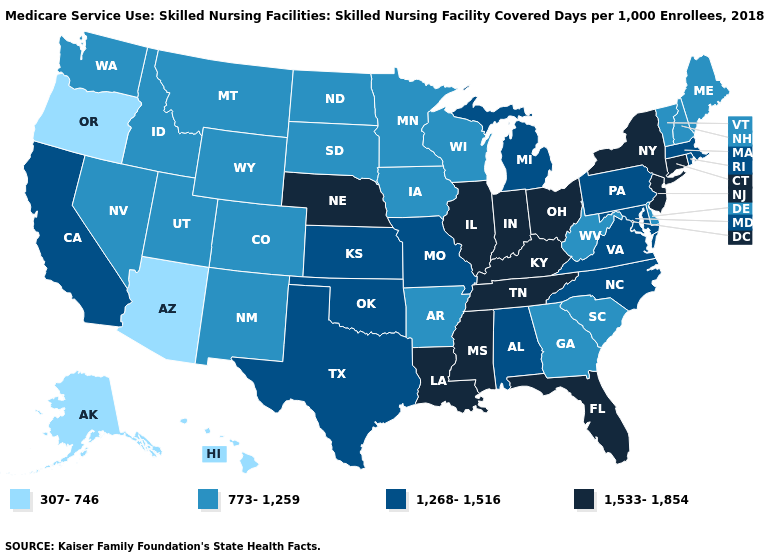Which states hav the highest value in the Northeast?
Concise answer only. Connecticut, New Jersey, New York. Which states have the lowest value in the Northeast?
Give a very brief answer. Maine, New Hampshire, Vermont. What is the value of Massachusetts?
Write a very short answer. 1,268-1,516. Name the states that have a value in the range 773-1,259?
Write a very short answer. Arkansas, Colorado, Delaware, Georgia, Idaho, Iowa, Maine, Minnesota, Montana, Nevada, New Hampshire, New Mexico, North Dakota, South Carolina, South Dakota, Utah, Vermont, Washington, West Virginia, Wisconsin, Wyoming. Name the states that have a value in the range 307-746?
Keep it brief. Alaska, Arizona, Hawaii, Oregon. Does California have the highest value in the West?
Be succinct. Yes. Name the states that have a value in the range 1,533-1,854?
Keep it brief. Connecticut, Florida, Illinois, Indiana, Kentucky, Louisiana, Mississippi, Nebraska, New Jersey, New York, Ohio, Tennessee. Does the first symbol in the legend represent the smallest category?
Quick response, please. Yes. Name the states that have a value in the range 1,268-1,516?
Concise answer only. Alabama, California, Kansas, Maryland, Massachusetts, Michigan, Missouri, North Carolina, Oklahoma, Pennsylvania, Rhode Island, Texas, Virginia. Does Washington have the same value as Arkansas?
Concise answer only. Yes. Does Florida have the highest value in the USA?
Be succinct. Yes. Name the states that have a value in the range 1,268-1,516?
Concise answer only. Alabama, California, Kansas, Maryland, Massachusetts, Michigan, Missouri, North Carolina, Oklahoma, Pennsylvania, Rhode Island, Texas, Virginia. What is the value of New Hampshire?
Give a very brief answer. 773-1,259. What is the highest value in the USA?
Give a very brief answer. 1,533-1,854. 